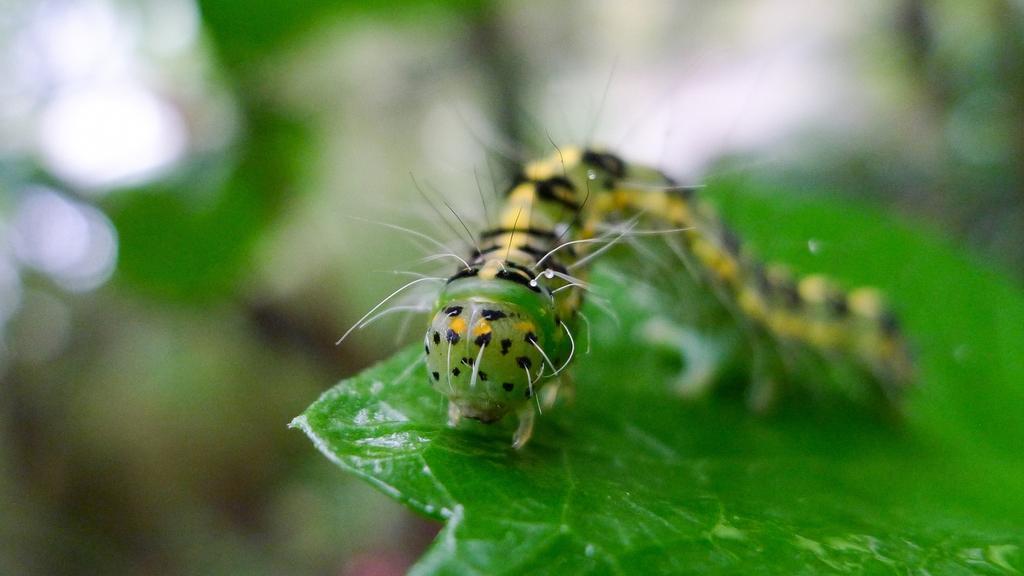How would you summarize this image in a sentence or two? In this image there is a caterpillar crawls on a leaf. 